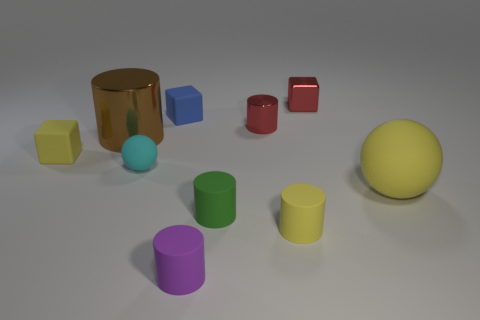What size is the brown metallic object that is the same shape as the tiny purple matte object?
Ensure brevity in your answer.  Large. Is the shape of the tiny purple rubber object the same as the small green object?
Offer a terse response. Yes. Are there fewer blue rubber objects that are left of the cyan matte sphere than yellow rubber cylinders that are left of the shiny cube?
Make the answer very short. Yes. How many small green rubber cylinders are to the right of the red metallic cylinder?
Offer a terse response. 0. Is the shape of the yellow object to the left of the cyan object the same as the small yellow object to the right of the large brown cylinder?
Offer a very short reply. No. How many other objects are there of the same color as the small ball?
Your answer should be compact. 0. What material is the large thing on the right side of the tiny yellow thing on the right side of the large thing left of the big yellow thing?
Keep it short and to the point. Rubber. What is the small yellow object to the left of the small red metallic thing that is to the left of the red metallic cube made of?
Make the answer very short. Rubber. Is the number of tiny red metallic objects left of the big brown cylinder less than the number of tiny purple rubber spheres?
Your response must be concise. No. There is a rubber thing on the left side of the brown metal cylinder; what shape is it?
Provide a short and direct response. Cube. 